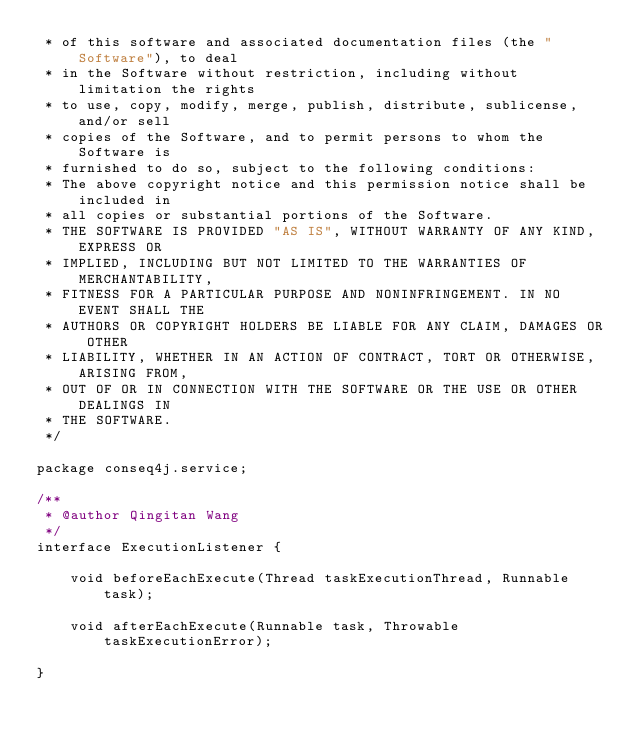Convert code to text. <code><loc_0><loc_0><loc_500><loc_500><_Java_> * of this software and associated documentation files (the "Software"), to deal
 * in the Software without restriction, including without limitation the rights
 * to use, copy, modify, merge, publish, distribute, sublicense, and/or sell
 * copies of the Software, and to permit persons to whom the Software is
 * furnished to do so, subject to the following conditions:
 * The above copyright notice and this permission notice shall be included in
 * all copies or substantial portions of the Software.
 * THE SOFTWARE IS PROVIDED "AS IS", WITHOUT WARRANTY OF ANY KIND, EXPRESS OR
 * IMPLIED, INCLUDING BUT NOT LIMITED TO THE WARRANTIES OF MERCHANTABILITY,
 * FITNESS FOR A PARTICULAR PURPOSE AND NONINFRINGEMENT. IN NO EVENT SHALL THE
 * AUTHORS OR COPYRIGHT HOLDERS BE LIABLE FOR ANY CLAIM, DAMAGES OR OTHER
 * LIABILITY, WHETHER IN AN ACTION OF CONTRACT, TORT OR OTHERWISE, ARISING FROM,
 * OUT OF OR IN CONNECTION WITH THE SOFTWARE OR THE USE OR OTHER DEALINGS IN
 * THE SOFTWARE.
 */

package conseq4j.service;

/**
 * @author Qingitan Wang
 */
interface ExecutionListener {

    void beforeEachExecute(Thread taskExecutionThread, Runnable task);

    void afterEachExecute(Runnable task, Throwable taskExecutionError);

}
</code> 